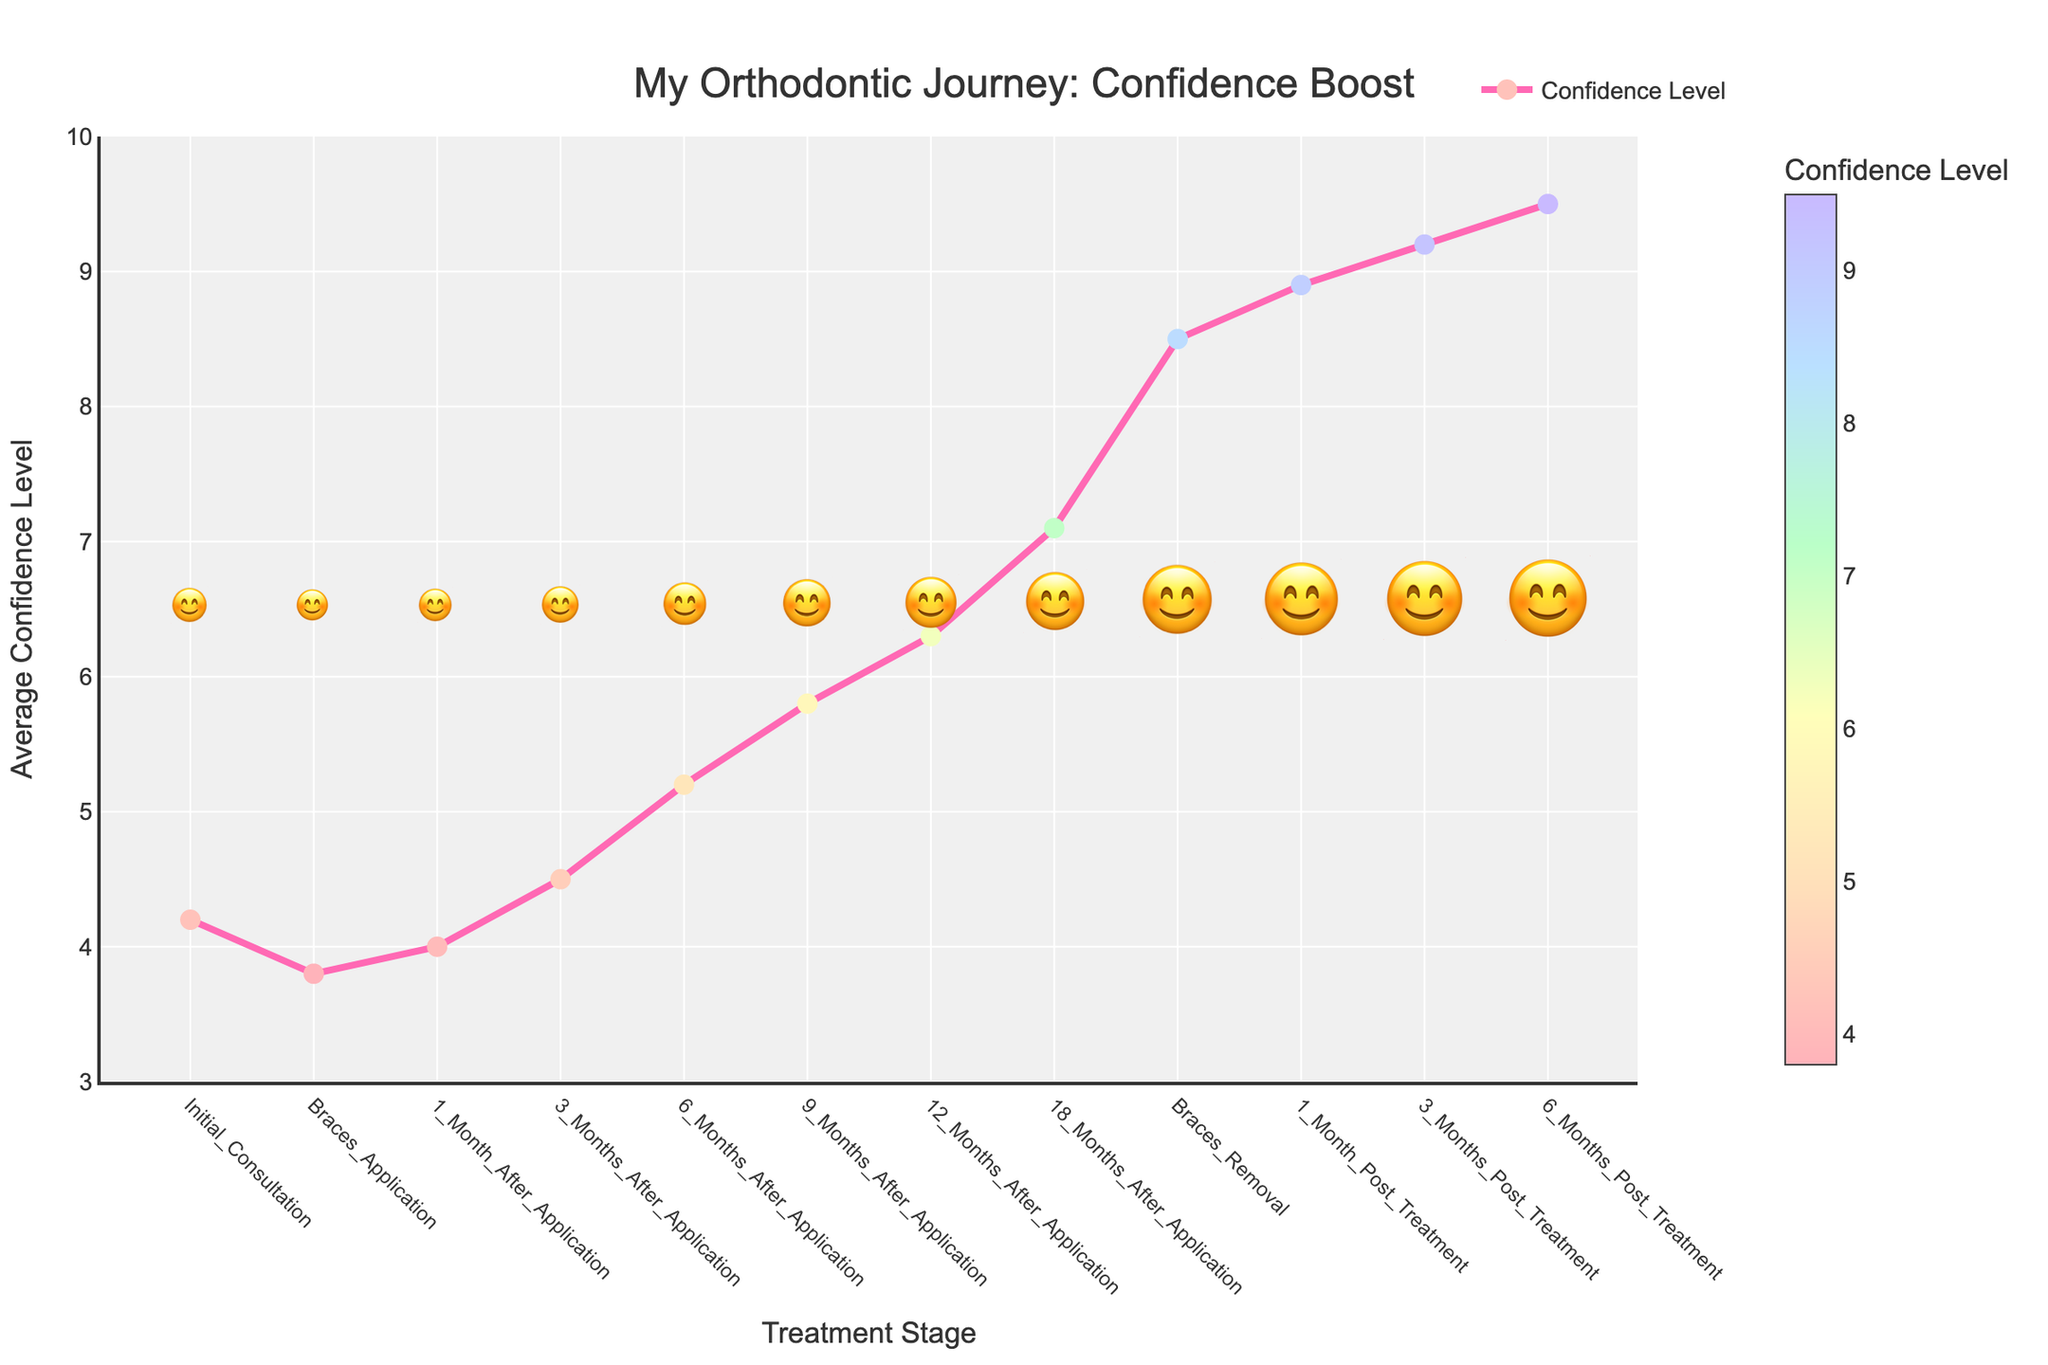What is the general trend of confidence levels from the initial consultation to 6 months post-treatment? The confidence levels generally increase over the treatment period. The trend starts at 4.2 during the initial consultation, dips slightly to 3.8 at braces application, and then steadily rises, eventually reaching 9.5 at 6 months post-treatment.
Answer: Steady increase How does the confidence level at 1 month post-treatment compare to the initial consultation? At 1 month post-treatment, the confidence level is 8.9, which is significantly higher than the initial consultation's confidence level of 4.2.
Answer: Higher What is the difference in confidence levels between 3 months after braces application and 12 months after braces application? The confidence level at 3 months after application is 4.5, and at 12 months, it is 6.3. The difference is 6.3 - 4.5 = 1.8.
Answer: 1.8 What stage shows the highest jump in confidence levels? The highest jump in confidence levels is observed between 18 months after application (7.1) and braces removal (8.5). The difference is 8.5 - 7.1 = 1.4.
Answer: Between 18 months after application and braces removal At which treatment stage does the confidence level reach exactly 8.5? The confidence level reaches exactly 8.5 at the 'Braces Removal' stage.
Answer: Braces Removal How much does the confidence level increase from 6 months after application to 9 months after application? The confidence level at 6 months after application is 5.2, and at 9 months after application, it is 5.8. The increase is 5.8 - 5.2 = 0.6.
Answer: 0.6 What is the average confidence level at 6 months and 12 months post-treatment? The confidence level at 6 months post-treatment is 9.5, and at 12 months post-treatment, it is 9.2. The average is (9.5 + 9.2) / 2 = 9.35.
Answer: 9.35 How many stages have confidence levels greater than 5? Stages with confidence levels greater than 5 are: 6 months after application, 9 months after application, 12 months after application, 18 months after application, braces removal, 1 month post-treatment, 3 months post-treatment, and 6 months post-treatment. There are 8 such stages.
Answer: 8 